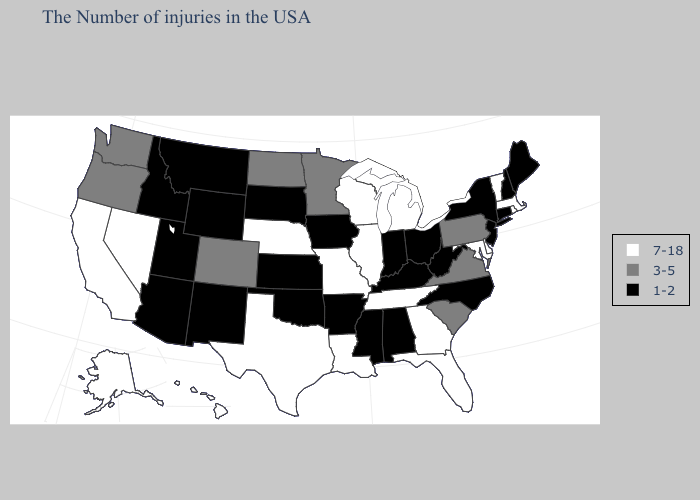Name the states that have a value in the range 7-18?
Write a very short answer. Massachusetts, Rhode Island, Vermont, Delaware, Maryland, Florida, Georgia, Michigan, Tennessee, Wisconsin, Illinois, Louisiana, Missouri, Nebraska, Texas, Nevada, California, Alaska, Hawaii. Does the map have missing data?
Concise answer only. No. Among the states that border South Dakota , does Iowa have the highest value?
Keep it brief. No. Does the map have missing data?
Write a very short answer. No. Does Ohio have the highest value in the USA?
Be succinct. No. What is the value of Kentucky?
Concise answer only. 1-2. What is the value of Washington?
Concise answer only. 3-5. What is the value of Montana?
Quick response, please. 1-2. Among the states that border South Carolina , which have the lowest value?
Write a very short answer. North Carolina. What is the highest value in the USA?
Keep it brief. 7-18. Which states have the lowest value in the USA?
Concise answer only. Maine, New Hampshire, Connecticut, New York, New Jersey, North Carolina, West Virginia, Ohio, Kentucky, Indiana, Alabama, Mississippi, Arkansas, Iowa, Kansas, Oklahoma, South Dakota, Wyoming, New Mexico, Utah, Montana, Arizona, Idaho. What is the value of New Mexico?
Concise answer only. 1-2. What is the value of South Carolina?
Short answer required. 3-5. What is the lowest value in the USA?
Quick response, please. 1-2. Which states have the lowest value in the South?
Write a very short answer. North Carolina, West Virginia, Kentucky, Alabama, Mississippi, Arkansas, Oklahoma. 